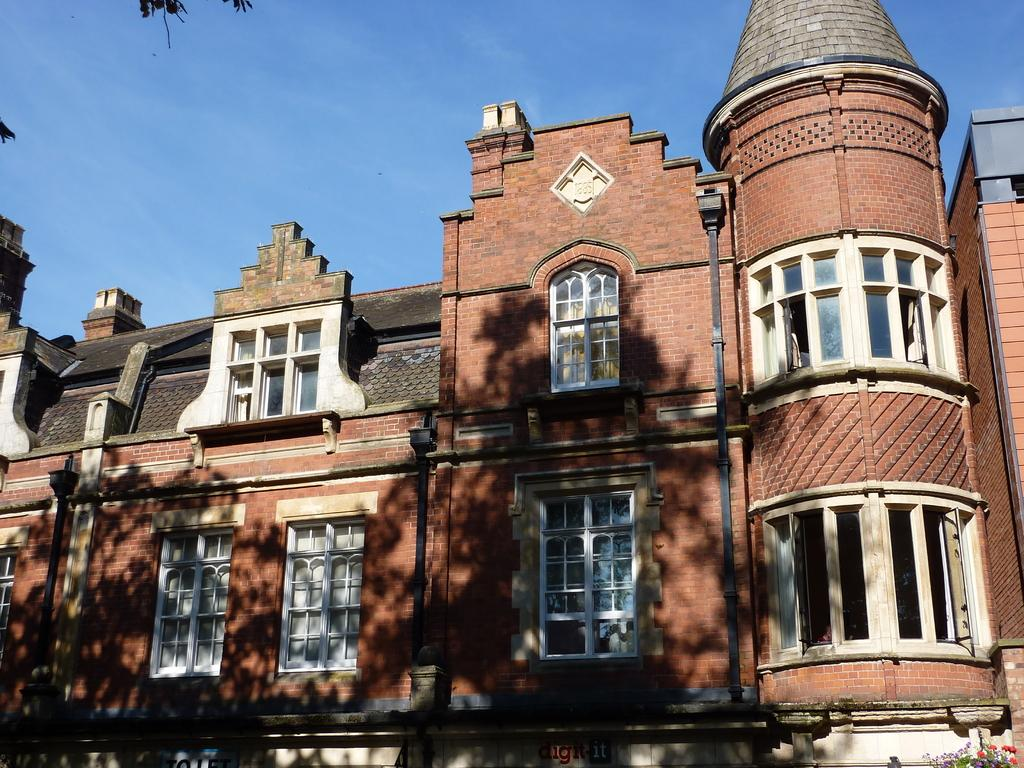What type of structure is present in the image? There is a building in the image. What else can be seen in the image besides the building? There are pipes and a reflection of trees visible in the image. What is visible in the background of the image? The sky is visible in the image. What type of lunch is the cow eating in the image? There is no cow or lunch present in the image. 